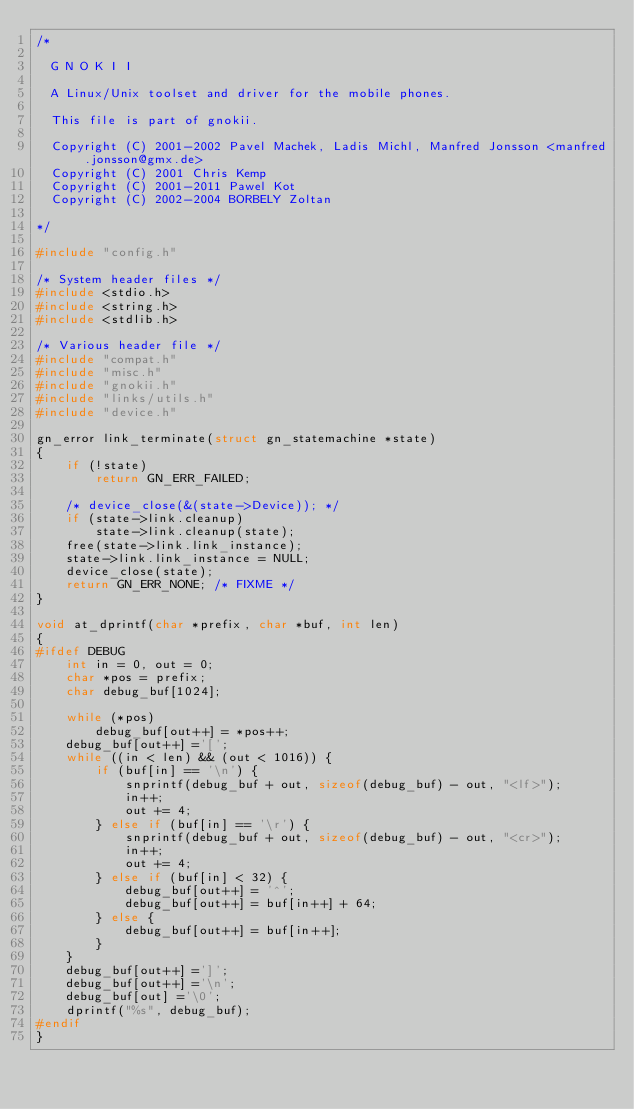<code> <loc_0><loc_0><loc_500><loc_500><_C_>/*

  G N O K I I

  A Linux/Unix toolset and driver for the mobile phones.

  This file is part of gnokii.

  Copyright (C) 2001-2002 Pavel Machek, Ladis Michl, Manfred Jonsson <manfred.jonsson@gmx.de>
  Copyright (C) 2001 Chris Kemp
  Copyright (C) 2001-2011 Pawel Kot
  Copyright (C) 2002-2004 BORBELY Zoltan

*/

#include "config.h"

/* System header files */
#include <stdio.h>
#include <string.h>
#include <stdlib.h>

/* Various header file */
#include "compat.h"
#include "misc.h"
#include "gnokii.h"
#include "links/utils.h"
#include "device.h"

gn_error link_terminate(struct gn_statemachine *state)
{
	if (!state)
		return GN_ERR_FAILED;

	/* device_close(&(state->Device)); */
	if (state->link.cleanup)
		state->link.cleanup(state);
	free(state->link.link_instance);
	state->link.link_instance = NULL;
	device_close(state);
	return GN_ERR_NONE; /* FIXME */
}

void at_dprintf(char *prefix, char *buf, int len)
{
#ifdef DEBUG
	int in = 0, out = 0;
	char *pos = prefix;
	char debug_buf[1024];

	while (*pos)
		debug_buf[out++] = *pos++;
	debug_buf[out++] ='[';
	while ((in < len) && (out < 1016)) {
		if (buf[in] == '\n') {
			snprintf(debug_buf + out, sizeof(debug_buf) - out, "<lf>");
			in++;
			out += 4;
		} else if (buf[in] == '\r') {
			snprintf(debug_buf + out, sizeof(debug_buf) - out, "<cr>");
			in++;
			out += 4;
		} else if (buf[in] < 32) {
			debug_buf[out++] = '^';
			debug_buf[out++] = buf[in++] + 64;
		} else {
			debug_buf[out++] = buf[in++];
		}
	}
	debug_buf[out++] =']';
	debug_buf[out++] ='\n';
	debug_buf[out] ='\0';
	dprintf("%s", debug_buf);
#endif
}
</code> 